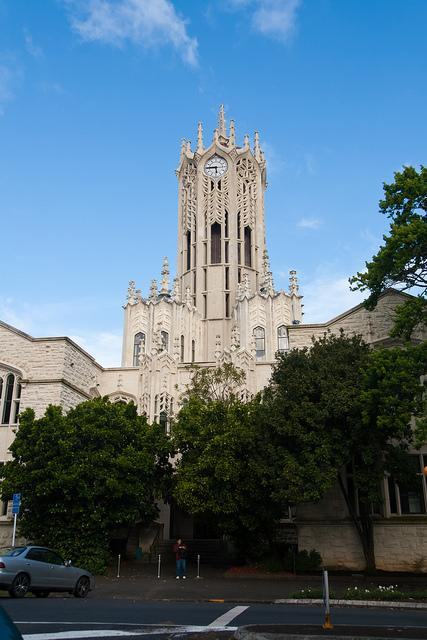What country is this building in?

Choices:
A) australia
B) england
C) china
D) russia australia 